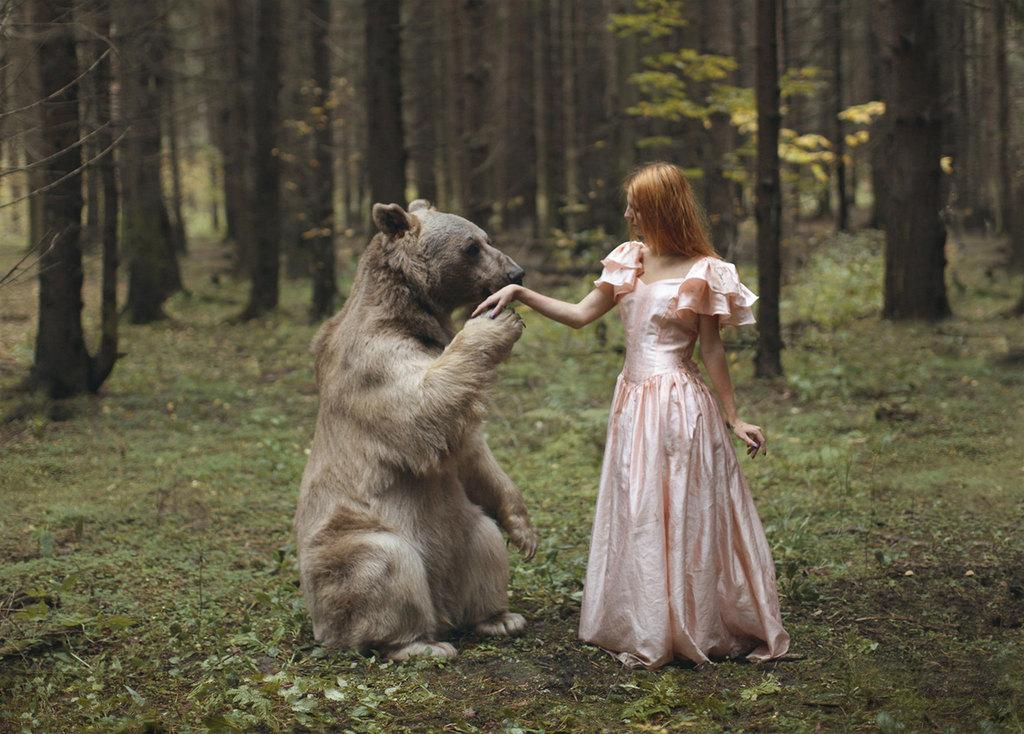Who is present in the image? There is a woman in the image. What other creature is present in the image? There is a bear in the image. Where are the woman and the bear located? Both the woman and the bear are on a path. What can be seen in the background of the image? There are trees and grass visible in the background of the image. What type of pollution can be seen in the image? There is no pollution visible in the image; it features a woman and a bear on a path with trees and grass in the background. 